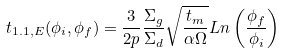Convert formula to latex. <formula><loc_0><loc_0><loc_500><loc_500>t _ { 1 . 1 , E } ( \phi _ { i } , \phi _ { f } ) = \frac { 3 } { 2 p } \frac { \Sigma _ { g } } { \Sigma _ { d } } \sqrt { \frac { t _ { m } } { \alpha \Omega } } { L n } \left ( \frac { \phi _ { f } } { \phi _ { i } } \right )</formula> 